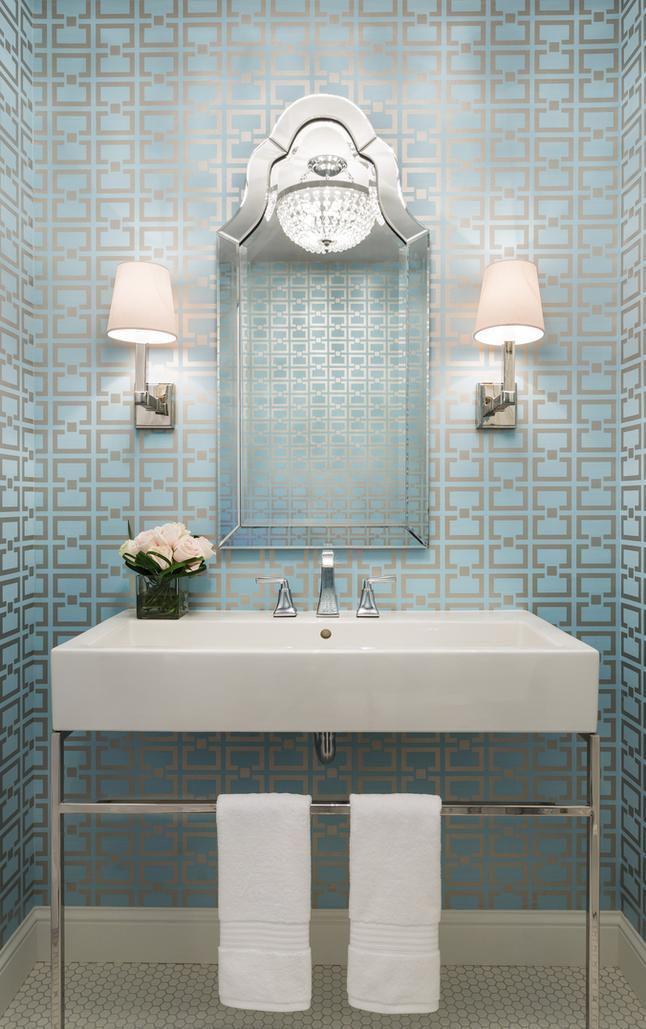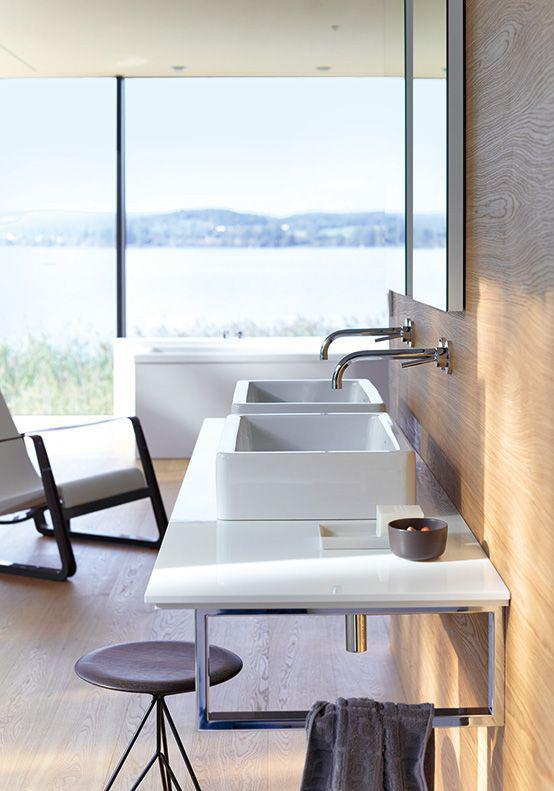The first image is the image on the left, the second image is the image on the right. Considering the images on both sides, is "In one image, a bathroom vanity has two matching white sinks." valid? Answer yes or no. Yes. 